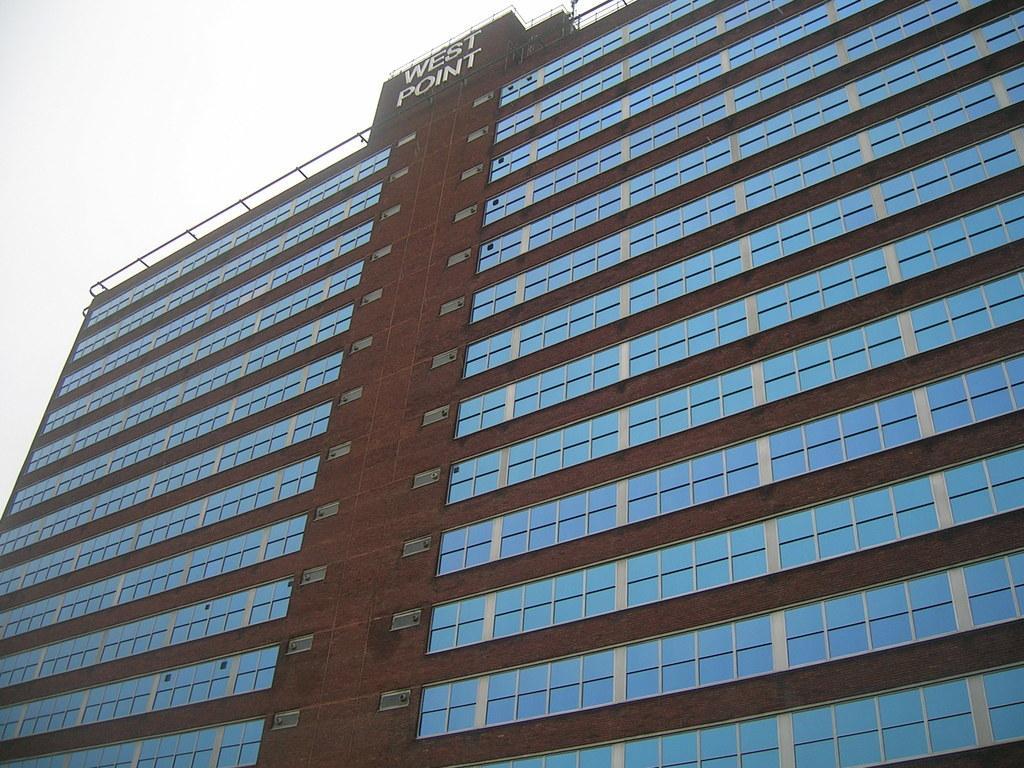Describe this image in one or two sentences. In this image we can see a building with windows. At the top we can see some text written on it. 